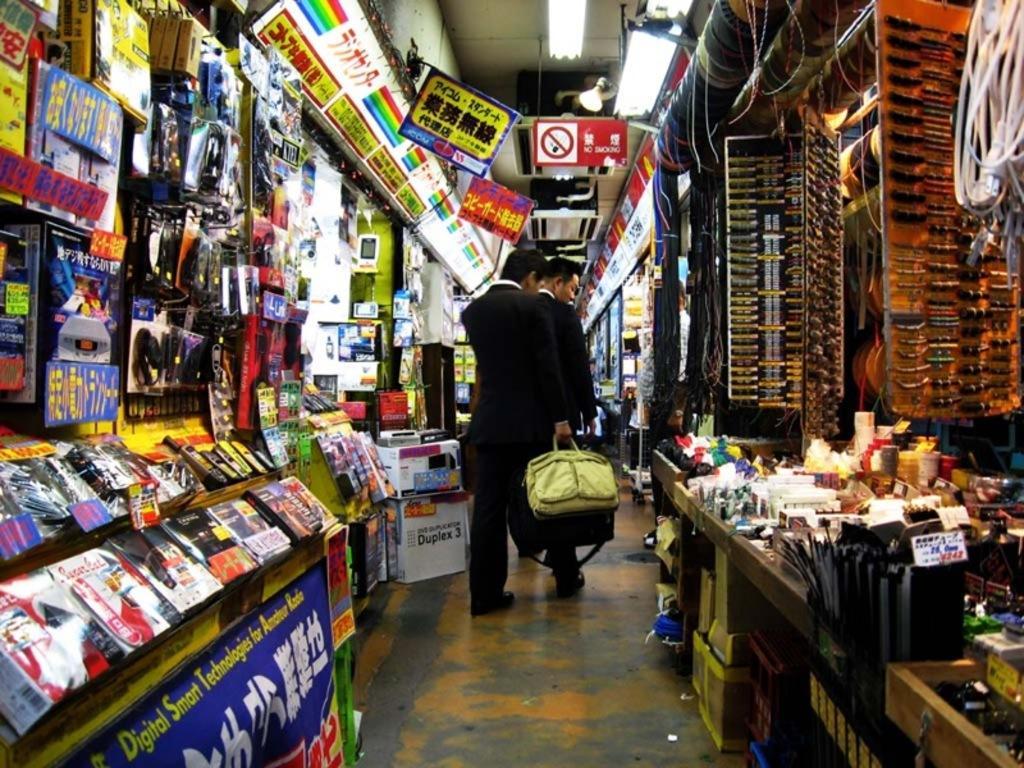Could you give a brief overview of what you see in this image? This picture we can observe two men walking in the grocery store. We can observe a green color bag in the hand of one of the men. We can observe a red color caution board and lights here. 